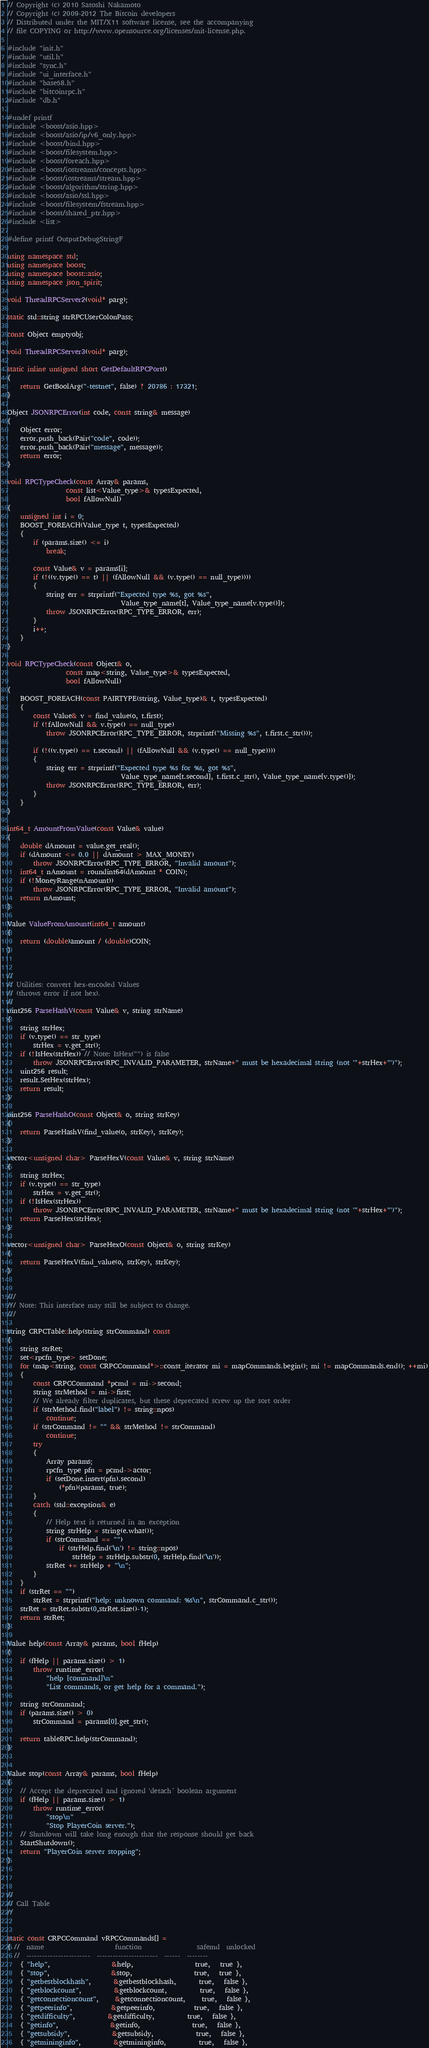<code> <loc_0><loc_0><loc_500><loc_500><_C++_>// Copyright (c) 2010 Satoshi Nakamoto
// Copyright (c) 2009-2012 The Bitcoin developers
// Distributed under the MIT/X11 software license, see the accompanying
// file COPYING or http://www.opensource.org/licenses/mit-license.php.

#include "init.h"
#include "util.h"
#include "sync.h"
#include "ui_interface.h"
#include "base58.h"
#include "bitcoinrpc.h"
#include "db.h"

#undef printf
#include <boost/asio.hpp>
#include <boost/asio/ip/v6_only.hpp>
#include <boost/bind.hpp>
#include <boost/filesystem.hpp>
#include <boost/foreach.hpp>
#include <boost/iostreams/concepts.hpp>
#include <boost/iostreams/stream.hpp>
#include <boost/algorithm/string.hpp>
#include <boost/asio/ssl.hpp>
#include <boost/filesystem/fstream.hpp>
#include <boost/shared_ptr.hpp>
#include <list>

#define printf OutputDebugStringF

using namespace std;
using namespace boost;
using namespace boost::asio;
using namespace json_spirit;

void ThreadRPCServer2(void* parg);

static std::string strRPCUserColonPass;

const Object emptyobj;

void ThreadRPCServer3(void* parg);

static inline unsigned short GetDefaultRPCPort()
{
    return GetBoolArg("-testnet", false) ? 20786 : 17321;
}

Object JSONRPCError(int code, const string& message)
{
    Object error;
    error.push_back(Pair("code", code));
    error.push_back(Pair("message", message));
    return error;
}

void RPCTypeCheck(const Array& params,
                  const list<Value_type>& typesExpected,
                  bool fAllowNull)
{
    unsigned int i = 0;
    BOOST_FOREACH(Value_type t, typesExpected)
    {
        if (params.size() <= i)
            break;

        const Value& v = params[i];
        if (!((v.type() == t) || (fAllowNull && (v.type() == null_type))))
        {
            string err = strprintf("Expected type %s, got %s",
                                   Value_type_name[t], Value_type_name[v.type()]);
            throw JSONRPCError(RPC_TYPE_ERROR, err);
        }
        i++;
    }
}

void RPCTypeCheck(const Object& o,
                  const map<string, Value_type>& typesExpected,
                  bool fAllowNull)
{
    BOOST_FOREACH(const PAIRTYPE(string, Value_type)& t, typesExpected)
    {
        const Value& v = find_value(o, t.first);
        if (!fAllowNull && v.type() == null_type)
            throw JSONRPCError(RPC_TYPE_ERROR, strprintf("Missing %s", t.first.c_str()));

        if (!((v.type() == t.second) || (fAllowNull && (v.type() == null_type))))
        {
            string err = strprintf("Expected type %s for %s, got %s",
                                   Value_type_name[t.second], t.first.c_str(), Value_type_name[v.type()]);
            throw JSONRPCError(RPC_TYPE_ERROR, err);
        }
    }
}

int64_t AmountFromValue(const Value& value)
{
    double dAmount = value.get_real();
    if (dAmount <= 0.0 || dAmount > MAX_MONEY)
        throw JSONRPCError(RPC_TYPE_ERROR, "Invalid amount");
    int64_t nAmount = roundint64(dAmount * COIN);
    if (!MoneyRange(nAmount))
        throw JSONRPCError(RPC_TYPE_ERROR, "Invalid amount");
    return nAmount;
}

Value ValueFromAmount(int64_t amount)
{
    return (double)amount / (double)COIN;
}


//
// Utilities: convert hex-encoded Values
// (throws error if not hex).
//
uint256 ParseHashV(const Value& v, string strName)
{
    string strHex;
    if (v.type() == str_type)
        strHex = v.get_str();
    if (!IsHex(strHex)) // Note: IsHex("") is false
        throw JSONRPCError(RPC_INVALID_PARAMETER, strName+" must be hexadecimal string (not '"+strHex+"')");
    uint256 result;
    result.SetHex(strHex);
    return result;
}

uint256 ParseHashO(const Object& o, string strKey)
{
    return ParseHashV(find_value(o, strKey), strKey);
}

vector<unsigned char> ParseHexV(const Value& v, string strName)
{
    string strHex;
    if (v.type() == str_type)
        strHex = v.get_str();
    if (!IsHex(strHex))
        throw JSONRPCError(RPC_INVALID_PARAMETER, strName+" must be hexadecimal string (not '"+strHex+"')");
    return ParseHex(strHex);
}

vector<unsigned char> ParseHexO(const Object& o, string strKey)
{
    return ParseHexV(find_value(o, strKey), strKey);
}


///
/// Note: This interface may still be subject to change.
///

string CRPCTable::help(string strCommand) const
{
    string strRet;
    set<rpcfn_type> setDone;
    for (map<string, const CRPCCommand*>::const_iterator mi = mapCommands.begin(); mi != mapCommands.end(); ++mi)
    {
        const CRPCCommand *pcmd = mi->second;
        string strMethod = mi->first;
        // We already filter duplicates, but these deprecated screw up the sort order
        if (strMethod.find("label") != string::npos)
            continue;
        if (strCommand != "" && strMethod != strCommand)
            continue;
        try
        {
            Array params;
            rpcfn_type pfn = pcmd->actor;
            if (setDone.insert(pfn).second)
                (*pfn)(params, true);
        }
        catch (std::exception& e)
        {
            // Help text is returned in an exception
            string strHelp = string(e.what());
            if (strCommand == "")
                if (strHelp.find('\n') != string::npos)
                    strHelp = strHelp.substr(0, strHelp.find('\n'));
            strRet += strHelp + "\n";
        }
    }
    if (strRet == "")
        strRet = strprintf("help: unknown command: %s\n", strCommand.c_str());
    strRet = strRet.substr(0,strRet.size()-1);
    return strRet;
}

Value help(const Array& params, bool fHelp)
{
    if (fHelp || params.size() > 1)
        throw runtime_error(
            "help [command]\n"
            "List commands, or get help for a command.");

    string strCommand;
    if (params.size() > 0)
        strCommand = params[0].get_str();

    return tableRPC.help(strCommand);
}


Value stop(const Array& params, bool fHelp)
{
    // Accept the deprecated and ignored 'detach´ boolean argument
    if (fHelp || params.size() > 1)
        throw runtime_error(
            "stop\n"
            "Stop PlayerCoin server.");
    // Shutdown will take long enough that the response should get back
    StartShutdown();
    return "PlayerCoin server stopping";
}



//
// Call Table
//


static const CRPCCommand vRPCCommands[] =
{ //  name                      function                 safemd  unlocked
  //  ------------------------  -----------------------  ------  --------
    { "help",                   &help,                   true,   true },
    { "stop",                   &stop,                   true,   true },
    { "getbestblockhash",       &getbestblockhash,       true,   false },
    { "getblockcount",          &getblockcount,          true,   false },
    { "getconnectioncount",     &getconnectioncount,     true,   false },
    { "getpeerinfo",            &getpeerinfo,            true,   false },
    { "getdifficulty",          &getdifficulty,          true,   false },
    { "getinfo",                &getinfo,                true,   false },
    { "getsubsidy",             &getsubsidy,             true,   false },
    { "getmininginfo",          &getmininginfo,          true,   false },</code> 